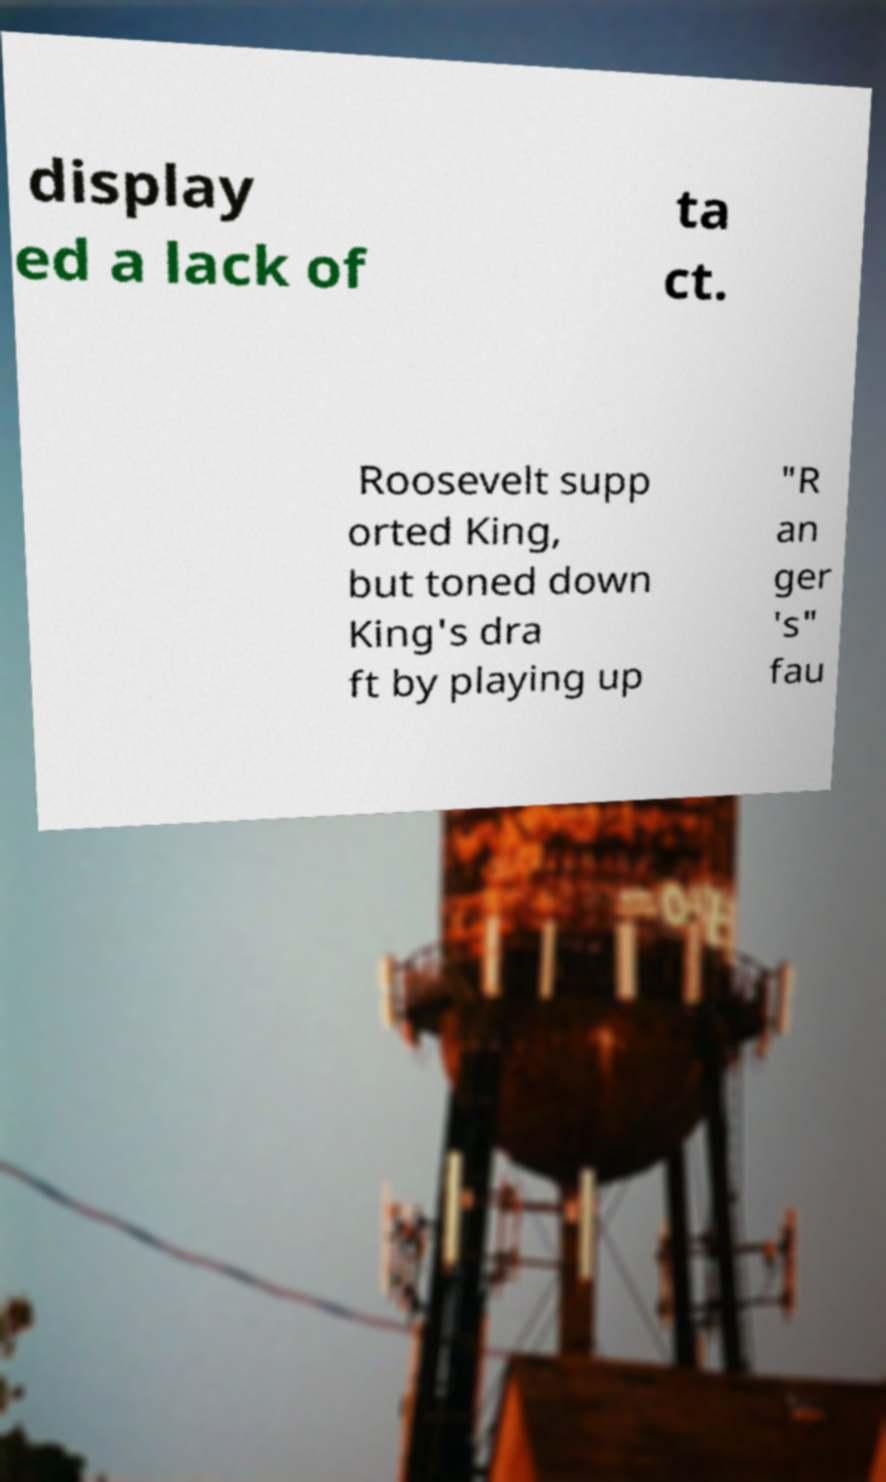Could you assist in decoding the text presented in this image and type it out clearly? display ed a lack of ta ct. Roosevelt supp orted King, but toned down King's dra ft by playing up "R an ger 's" fau 